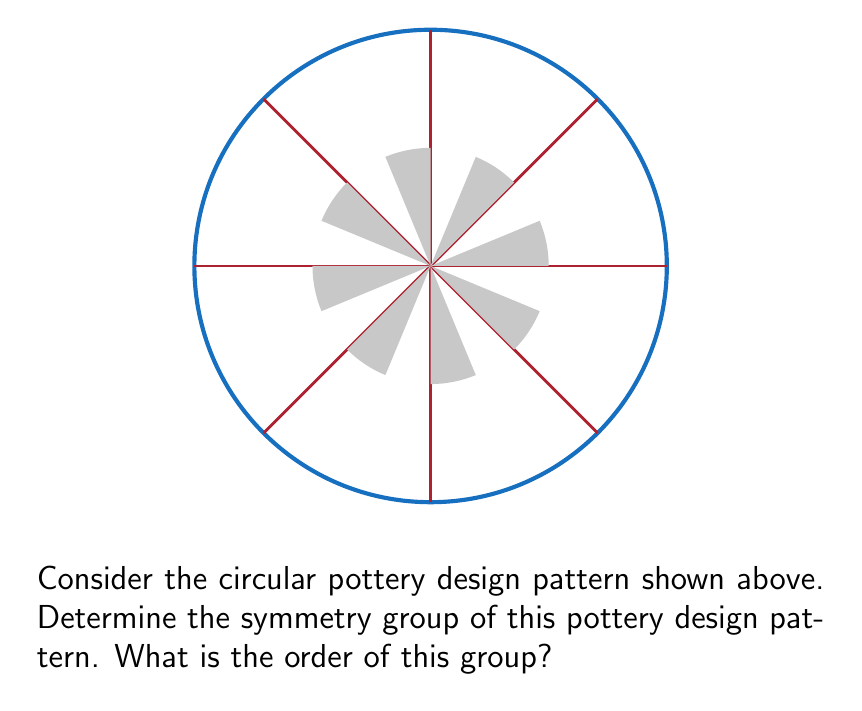Help me with this question. To determine the symmetry group of this pottery design pattern, we need to identify all the symmetry operations that leave the pattern unchanged. Let's analyze the pattern step-by-step:

1. Rotational symmetry:
   The pattern has 8-fold rotational symmetry. It remains unchanged when rotated by multiples of 45°. This gives us 8 rotational symmetries: 0°, 45°, 90°, 135°, 180°, 225°, 270°, and 315°.

2. Reflection symmetry:
   The pattern has 8 lines of reflection symmetry. These lines coincide with the 8 radial lines in the design.

3. Identity:
   The identity transformation (doing nothing) is always a symmetry.

The symmetry group that describes this pattern is the dihedral group $D_8$. The dihedral group $D_n$ is the group of symmetries of a regular n-gon, which includes n rotations and n reflections.

To determine the order of the group:
- Number of rotations: 8
- Number of reflections: 8
- Identity: 1

Total number of symmetries = 8 + 8 + 1 = 17

Therefore, the order of the symmetry group is 17.

In group theory notation, we can write this as $|D_8| = 17$.
Answer: $D_8$, order 17 